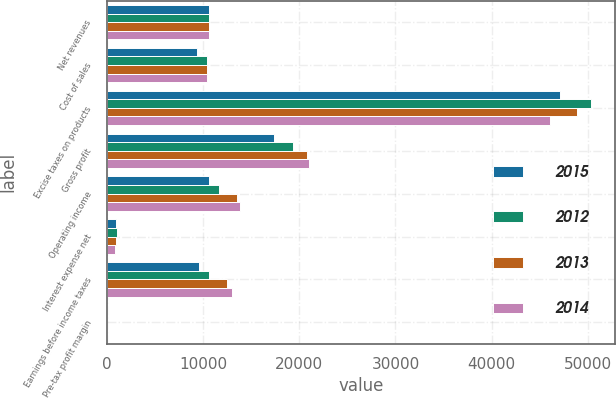<chart> <loc_0><loc_0><loc_500><loc_500><stacked_bar_chart><ecel><fcel>Net revenues<fcel>Cost of sales<fcel>Excise taxes on products<fcel>Gross profit<fcel>Operating income<fcel>Interest expense net<fcel>Earnings before income taxes<fcel>Pre-tax profit margin<nl><fcel>2015<fcel>10636.5<fcel>9365<fcel>47114<fcel>17429<fcel>10623<fcel>1008<fcel>9615<fcel>13<nl><fcel>2012<fcel>10636.5<fcel>10436<fcel>50339<fcel>19331<fcel>11702<fcel>1052<fcel>10650<fcel>13.3<nl><fcel>2013<fcel>10636.5<fcel>10410<fcel>48812<fcel>20807<fcel>13515<fcel>973<fcel>12542<fcel>15.7<nl><fcel>2014<fcel>10636.5<fcel>10373<fcel>46016<fcel>21004<fcel>13863<fcel>859<fcel>13004<fcel>16.8<nl></chart> 